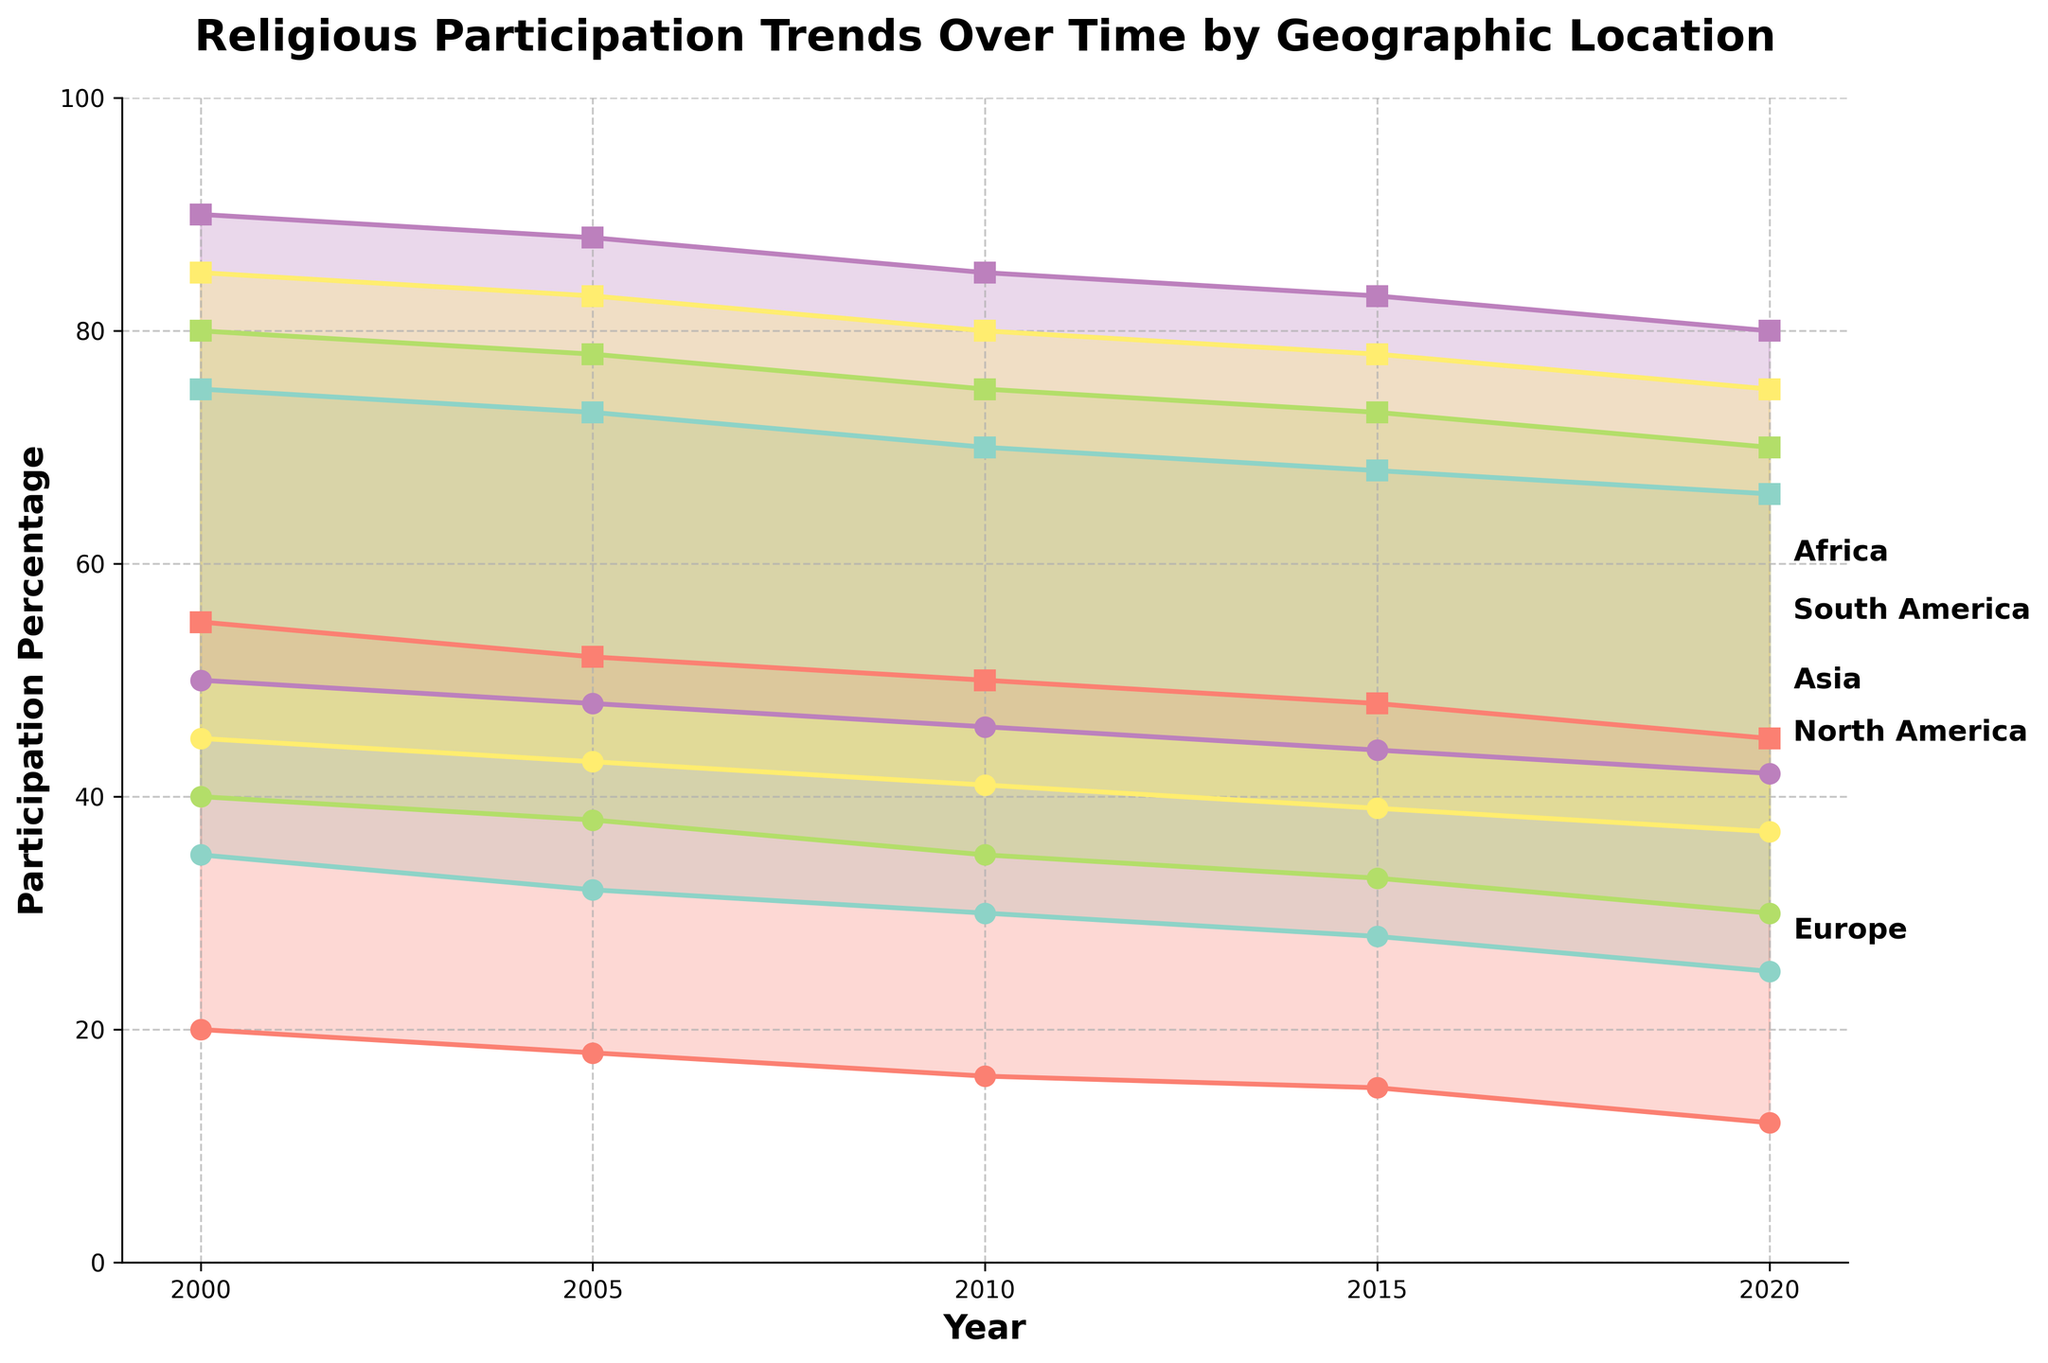What is the title of the chart? The title of the chart can be found at the top of the figure. Reading it directly from the chart, it states "Religious Participation Trends Over Time by Geographic Location".
Answer: Religious Participation Trends Over Time by Geographic Location What is the minimum participation percentage for North America in 2020? To find the answer, locate North America on the chart and find the year 2020. The minimum participation percentage for that year is the lower bound of the shaded area for North America. It is 25%.
Answer: 25% Which geographic location had the highest maximum participation percentage in 2000? To determine the highest maximum participation percentage in 2000, refer to the top ends of the shaded areas for each geographic location in the year 2000. Africa had the highest maximum participation percentage at 90%.
Answer: Africa How did the maximum participation percentage in Asia change from 2000 to 2020? Compare the maximum participation percentages for Asia in 2000 and 2020. In 2000, it was 80%, and in 2020, it was 70%. The change is 80% - 70% = 10%.
Answer: Decreased by 10% For which geographic location is there the smallest difference between minimum and maximum participation percentages in 2015? Find the difference between the minimum and maximum participation percentages for each geographic location in 2015 by subtracting the minimum from the maximum. South America's difference is 78-39=39, Africa's is 83-44=39, Europe's is 48-15=33, Asia's is 73-33=40, and North America's is 68-28=40. The smallest difference is in Europe at 33%.
Answer: Europe What is the general trend of religious participation in North America from 2000 to 2020? Observe the shaded area representing North America from 2000 to 2020. Both the minimum and maximum participation percentages are decreasing, indicating a downward trend.
Answer: Downward trend How does the range of participation percentages in Africa compare to that in Europe in 2020? Compare the participation range (maximum percentage - minimum percentage) for Africa and Europe in 2020. Africa has a range of 80-42=38%, while Europe has a range of 45-12=33%. Africa has a larger range.
Answer: Africa has a larger range In which year did South America have the minimum participation percentage of 41%? Check each data point's values for South America and find the year corresponding to a minimum participation percentage of 41%. It is in the year 2010.
Answer: 2010 Which geographic location shows the least variation in participation percentages over the 20-year period? Examine the shaded areas and the spread between the minimum and maximum participation percentages over the years for each location. Europe shows the least variation as the changes in the heights of the shaded area are relatively smaller compared to other regions.
Answer: Europe Comparatively, how did the overall participation trends for North America and Africa differ from 2000 to 2020? Analyze the shaded areas for North America and Africa from 2000 to 2020. North America shows a consistent decline in both minimum and maximum participation percentages, while Africa also shows a decline but at a slower rate and with higher overall percentages throughout.
Answer: North America shows a steeper decline; Africa shows a slower decline 